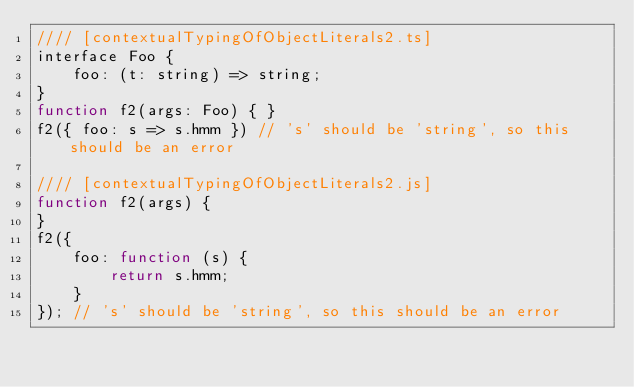Convert code to text. <code><loc_0><loc_0><loc_500><loc_500><_JavaScript_>//// [contextualTypingOfObjectLiterals2.ts]
interface Foo {
    foo: (t: string) => string;
}
function f2(args: Foo) { }
f2({ foo: s => s.hmm }) // 's' should be 'string', so this should be an error

//// [contextualTypingOfObjectLiterals2.js]
function f2(args) {
}
f2({
    foo: function (s) {
        return s.hmm;
    }
}); // 's' should be 'string', so this should be an error
</code> 